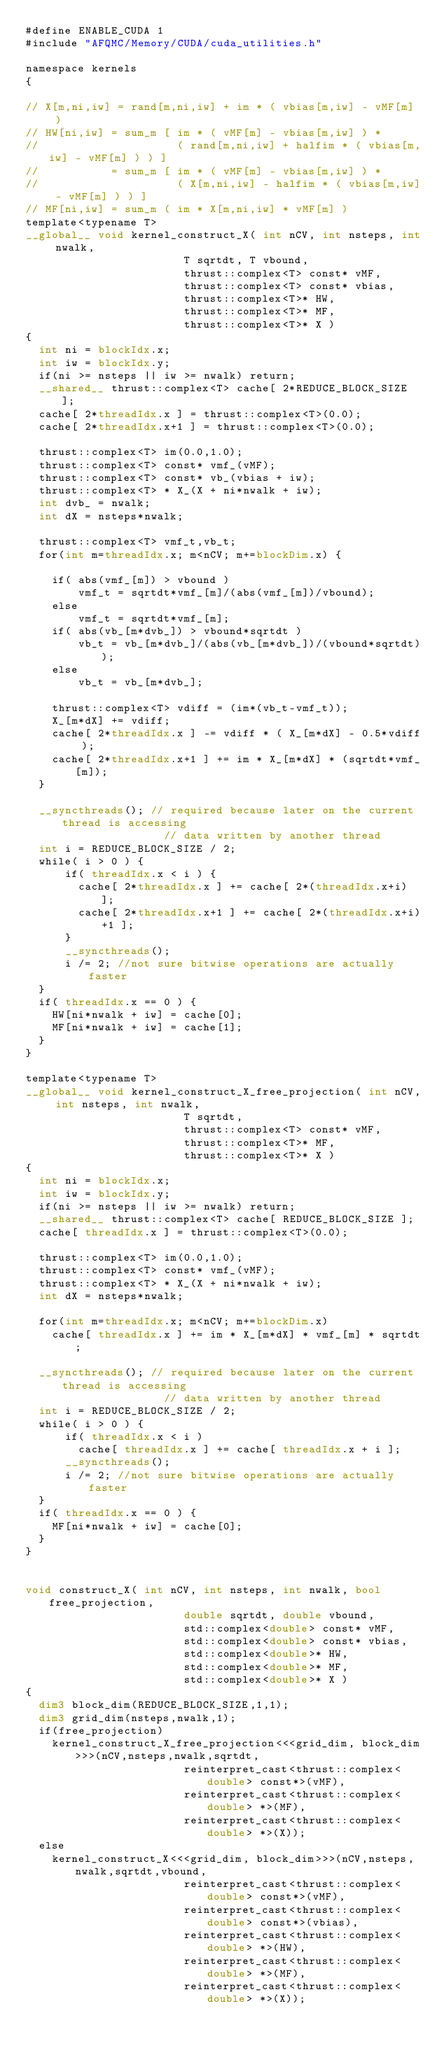Convert code to text. <code><loc_0><loc_0><loc_500><loc_500><_Cuda_>#define ENABLE_CUDA 1
#include "AFQMC/Memory/CUDA/cuda_utilities.h"

namespace kernels
{

// X[m,ni,iw] = rand[m,ni,iw] + im * ( vbias[m,iw] - vMF[m]  )
// HW[ni,iw] = sum_m [ im * ( vMF[m] - vbias[m,iw] ) * 
//                     ( rand[m,ni,iw] + halfim * ( vbias[m,iw] - vMF[m] ) ) ] 
//           = sum_m [ im * ( vMF[m] - vbias[m,iw] ) * 
//                     ( X[m,ni,iw] - halfim * ( vbias[m,iw] - vMF[m] ) ) ] 
// MF[ni,iw] = sum_m ( im * X[m,ni,iw] * vMF[m] ) 
template<typename T>
__global__ void kernel_construct_X( int nCV, int nsteps, int nwalk, 
                        T sqrtdt, T vbound,
                        thrust::complex<T> const* vMF, 
                        thrust::complex<T> const* vbias,   
                        thrust::complex<T>* HW,   
                        thrust::complex<T>* MF,   
                        thrust::complex<T>* X ) 
{
  int ni = blockIdx.x;  
  int iw = blockIdx.y;  
  if(ni >= nsteps || iw >= nwalk) return;  
  __shared__ thrust::complex<T> cache[ 2*REDUCE_BLOCK_SIZE ];
  cache[ 2*threadIdx.x ] = thrust::complex<T>(0.0);
  cache[ 2*threadIdx.x+1 ] = thrust::complex<T>(0.0);

  thrust::complex<T> im(0.0,1.0);
  thrust::complex<T> const* vmf_(vMF); 
  thrust::complex<T> const* vb_(vbias + iw); 
  thrust::complex<T> * X_(X + ni*nwalk + iw); 
  int dvb_ = nwalk;
  int dX = nsteps*nwalk; 

  thrust::complex<T> vmf_t,vb_t; 
  for(int m=threadIdx.x; m<nCV; m+=blockDim.x) {

    if( abs(vmf_[m]) > vbound )
        vmf_t = sqrtdt*vmf_[m]/(abs(vmf_[m])/vbound);
    else
        vmf_t = sqrtdt*vmf_[m];
    if( abs(vb_[m*dvb_]) > vbound*sqrtdt )
        vb_t = vb_[m*dvb_]/(abs(vb_[m*dvb_])/(vbound*sqrtdt));
    else
        vb_t = vb_[m*dvb_];

    thrust::complex<T> vdiff = (im*(vb_t-vmf_t));
    X_[m*dX] += vdiff;
    cache[ 2*threadIdx.x ] -= vdiff * ( X_[m*dX] - 0.5*vdiff );
    cache[ 2*threadIdx.x+1 ] += im * X_[m*dX] * (sqrtdt*vmf_[m]);
  }

  __syncthreads(); // required because later on the current thread is accessing
                     // data written by another thread    
  int i = REDUCE_BLOCK_SIZE / 2;
  while( i > 0 ) {
      if( threadIdx.x < i ) {
        cache[ 2*threadIdx.x ] += cache[ 2*(threadIdx.x+i) ];
        cache[ 2*threadIdx.x+1 ] += cache[ 2*(threadIdx.x+i)+1 ];
      }
      __syncthreads();
      i /= 2; //not sure bitwise operations are actually faster
  }
  if( threadIdx.x == 0 ) {
    HW[ni*nwalk + iw] = cache[0]; 
    MF[ni*nwalk + iw] = cache[1]; 
  }
}

template<typename T>
__global__ void kernel_construct_X_free_projection( int nCV, int nsteps, int nwalk, 
                        T sqrtdt,
                        thrust::complex<T> const* vMF, 
                        thrust::complex<T>* MF,   
                        thrust::complex<T>* X ) 
{
  int ni = blockIdx.x;  
  int iw = blockIdx.y;  
  if(ni >= nsteps || iw >= nwalk) return;  
  __shared__ thrust::complex<T> cache[ REDUCE_BLOCK_SIZE ];
  cache[ threadIdx.x ] = thrust::complex<T>(0.0);

  thrust::complex<T> im(0.0,1.0);
  thrust::complex<T> const* vmf_(vMF); 
  thrust::complex<T> * X_(X + ni*nwalk + iw); 
  int dX = nsteps*nwalk; 

  for(int m=threadIdx.x; m<nCV; m+=blockDim.x) 
    cache[ threadIdx.x ] += im * X_[m*dX] * vmf_[m] * sqrtdt;

  __syncthreads(); // required because later on the current thread is accessing
                     // data written by another thread    
  int i = REDUCE_BLOCK_SIZE / 2;
  while( i > 0 ) {
      if( threadIdx.x < i ) 
        cache[ threadIdx.x ] += cache[ threadIdx.x + i ];
      __syncthreads();
      i /= 2; //not sure bitwise operations are actually faster
  }
  if( threadIdx.x == 0 ) {
    MF[ni*nwalk + iw] = cache[0]; 
  }
}


void construct_X( int nCV, int nsteps, int nwalk, bool free_projection, 
                        double sqrtdt, double vbound,
                        std::complex<double> const* vMF,
                        std::complex<double> const* vbias,
                        std::complex<double>* HW,
                        std::complex<double>* MF,
                        std::complex<double>* X )
{
  dim3 block_dim(REDUCE_BLOCK_SIZE,1,1);
  dim3 grid_dim(nsteps,nwalk,1);
  if(free_projection)
    kernel_construct_X_free_projection<<<grid_dim, block_dim>>>(nCV,nsteps,nwalk,sqrtdt,
                        reinterpret_cast<thrust::complex<double> const*>(vMF),
                        reinterpret_cast<thrust::complex<double> *>(MF),
                        reinterpret_cast<thrust::complex<double> *>(X));
  else
    kernel_construct_X<<<grid_dim, block_dim>>>(nCV,nsteps,nwalk,sqrtdt,vbound,
                        reinterpret_cast<thrust::complex<double> const*>(vMF),
                        reinterpret_cast<thrust::complex<double> const*>(vbias),
                        reinterpret_cast<thrust::complex<double> *>(HW),
                        reinterpret_cast<thrust::complex<double> *>(MF),
                        reinterpret_cast<thrust::complex<double> *>(X));</code> 